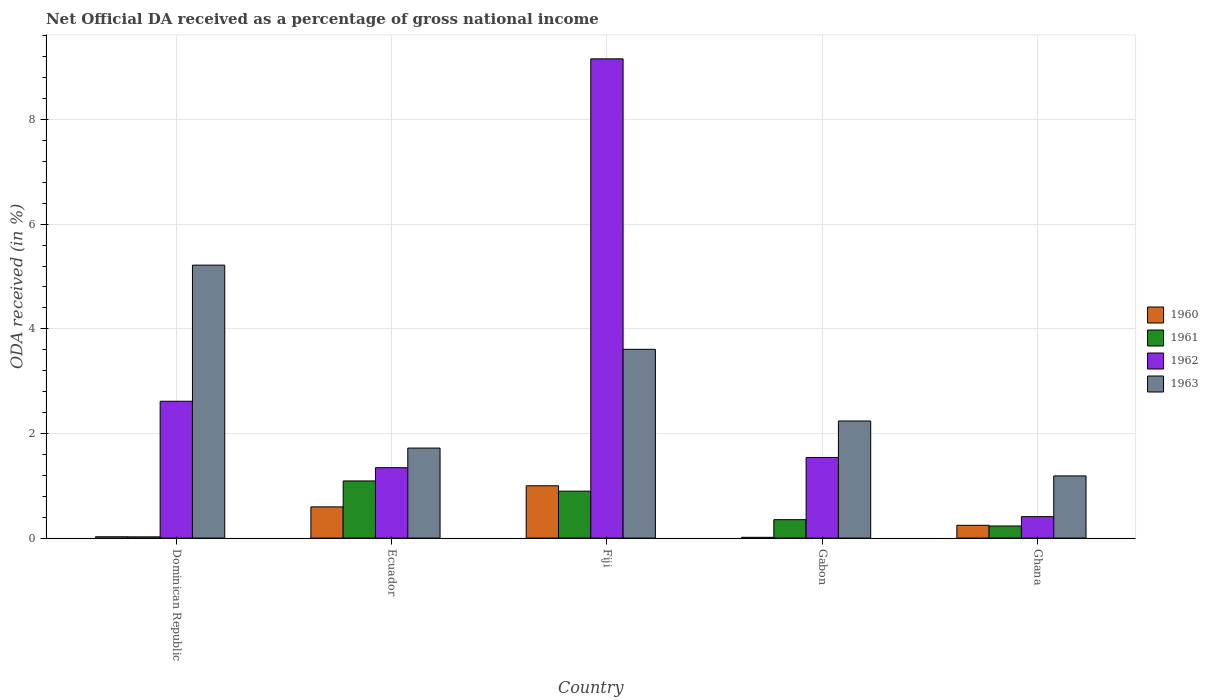How many bars are there on the 1st tick from the left?
Your answer should be very brief. 4. What is the label of the 4th group of bars from the left?
Your answer should be compact. Gabon. In how many cases, is the number of bars for a given country not equal to the number of legend labels?
Offer a terse response. 0. What is the net official DA received in 1963 in Gabon?
Give a very brief answer. 2.24. Across all countries, what is the maximum net official DA received in 1961?
Your response must be concise. 1.09. Across all countries, what is the minimum net official DA received in 1960?
Ensure brevity in your answer.  0.01. In which country was the net official DA received in 1962 maximum?
Make the answer very short. Fiji. In which country was the net official DA received in 1960 minimum?
Keep it short and to the point. Gabon. What is the total net official DA received in 1960 in the graph?
Provide a succinct answer. 1.88. What is the difference between the net official DA received in 1961 in Gabon and that in Ghana?
Provide a succinct answer. 0.12. What is the difference between the net official DA received in 1962 in Fiji and the net official DA received in 1963 in Gabon?
Offer a terse response. 6.92. What is the average net official DA received in 1960 per country?
Provide a short and direct response. 0.38. What is the difference between the net official DA received of/in 1962 and net official DA received of/in 1963 in Ghana?
Keep it short and to the point. -0.78. In how many countries, is the net official DA received in 1961 greater than 3.6 %?
Ensure brevity in your answer.  0. What is the ratio of the net official DA received in 1960 in Gabon to that in Ghana?
Give a very brief answer. 0.06. What is the difference between the highest and the second highest net official DA received in 1962?
Provide a succinct answer. 6.54. What is the difference between the highest and the lowest net official DA received in 1963?
Keep it short and to the point. 4.03. In how many countries, is the net official DA received in 1960 greater than the average net official DA received in 1960 taken over all countries?
Give a very brief answer. 2. Is the sum of the net official DA received in 1963 in Gabon and Ghana greater than the maximum net official DA received in 1961 across all countries?
Your answer should be very brief. Yes. How many bars are there?
Your response must be concise. 20. What is the difference between two consecutive major ticks on the Y-axis?
Your answer should be compact. 2. Does the graph contain grids?
Ensure brevity in your answer.  Yes. How many legend labels are there?
Keep it short and to the point. 4. What is the title of the graph?
Offer a terse response. Net Official DA received as a percentage of gross national income. Does "2009" appear as one of the legend labels in the graph?
Ensure brevity in your answer.  No. What is the label or title of the X-axis?
Your answer should be compact. Country. What is the label or title of the Y-axis?
Ensure brevity in your answer.  ODA received (in %). What is the ODA received (in %) in 1960 in Dominican Republic?
Your answer should be very brief. 0.03. What is the ODA received (in %) in 1961 in Dominican Republic?
Ensure brevity in your answer.  0.02. What is the ODA received (in %) in 1962 in Dominican Republic?
Make the answer very short. 2.62. What is the ODA received (in %) in 1963 in Dominican Republic?
Make the answer very short. 5.22. What is the ODA received (in %) of 1960 in Ecuador?
Your answer should be very brief. 0.6. What is the ODA received (in %) in 1961 in Ecuador?
Your answer should be very brief. 1.09. What is the ODA received (in %) of 1962 in Ecuador?
Keep it short and to the point. 1.35. What is the ODA received (in %) of 1963 in Ecuador?
Your response must be concise. 1.72. What is the ODA received (in %) of 1960 in Fiji?
Your response must be concise. 1. What is the ODA received (in %) in 1961 in Fiji?
Your response must be concise. 0.9. What is the ODA received (in %) in 1962 in Fiji?
Keep it short and to the point. 9.16. What is the ODA received (in %) in 1963 in Fiji?
Provide a succinct answer. 3.61. What is the ODA received (in %) of 1960 in Gabon?
Your answer should be very brief. 0.01. What is the ODA received (in %) of 1961 in Gabon?
Offer a terse response. 0.35. What is the ODA received (in %) of 1962 in Gabon?
Ensure brevity in your answer.  1.54. What is the ODA received (in %) in 1963 in Gabon?
Offer a terse response. 2.24. What is the ODA received (in %) in 1960 in Ghana?
Provide a succinct answer. 0.24. What is the ODA received (in %) in 1961 in Ghana?
Ensure brevity in your answer.  0.23. What is the ODA received (in %) of 1962 in Ghana?
Provide a succinct answer. 0.41. What is the ODA received (in %) of 1963 in Ghana?
Make the answer very short. 1.19. Across all countries, what is the maximum ODA received (in %) of 1960?
Keep it short and to the point. 1. Across all countries, what is the maximum ODA received (in %) in 1961?
Your response must be concise. 1.09. Across all countries, what is the maximum ODA received (in %) in 1962?
Provide a short and direct response. 9.16. Across all countries, what is the maximum ODA received (in %) of 1963?
Your response must be concise. 5.22. Across all countries, what is the minimum ODA received (in %) in 1960?
Provide a succinct answer. 0.01. Across all countries, what is the minimum ODA received (in %) of 1961?
Keep it short and to the point. 0.02. Across all countries, what is the minimum ODA received (in %) of 1962?
Provide a short and direct response. 0.41. Across all countries, what is the minimum ODA received (in %) of 1963?
Ensure brevity in your answer.  1.19. What is the total ODA received (in %) in 1960 in the graph?
Make the answer very short. 1.88. What is the total ODA received (in %) in 1961 in the graph?
Make the answer very short. 2.6. What is the total ODA received (in %) of 1962 in the graph?
Make the answer very short. 15.07. What is the total ODA received (in %) in 1963 in the graph?
Your answer should be very brief. 13.97. What is the difference between the ODA received (in %) of 1960 in Dominican Republic and that in Ecuador?
Provide a short and direct response. -0.57. What is the difference between the ODA received (in %) in 1961 in Dominican Republic and that in Ecuador?
Your answer should be very brief. -1.07. What is the difference between the ODA received (in %) of 1962 in Dominican Republic and that in Ecuador?
Provide a succinct answer. 1.27. What is the difference between the ODA received (in %) of 1963 in Dominican Republic and that in Ecuador?
Provide a short and direct response. 3.5. What is the difference between the ODA received (in %) in 1960 in Dominican Republic and that in Fiji?
Make the answer very short. -0.97. What is the difference between the ODA received (in %) in 1961 in Dominican Republic and that in Fiji?
Ensure brevity in your answer.  -0.87. What is the difference between the ODA received (in %) in 1962 in Dominican Republic and that in Fiji?
Offer a terse response. -6.54. What is the difference between the ODA received (in %) in 1963 in Dominican Republic and that in Fiji?
Your answer should be very brief. 1.61. What is the difference between the ODA received (in %) in 1960 in Dominican Republic and that in Gabon?
Provide a succinct answer. 0.01. What is the difference between the ODA received (in %) in 1961 in Dominican Republic and that in Gabon?
Your response must be concise. -0.33. What is the difference between the ODA received (in %) of 1962 in Dominican Republic and that in Gabon?
Your response must be concise. 1.07. What is the difference between the ODA received (in %) in 1963 in Dominican Republic and that in Gabon?
Provide a succinct answer. 2.98. What is the difference between the ODA received (in %) in 1960 in Dominican Republic and that in Ghana?
Offer a terse response. -0.22. What is the difference between the ODA received (in %) in 1961 in Dominican Republic and that in Ghana?
Offer a terse response. -0.21. What is the difference between the ODA received (in %) of 1962 in Dominican Republic and that in Ghana?
Keep it short and to the point. 2.21. What is the difference between the ODA received (in %) of 1963 in Dominican Republic and that in Ghana?
Make the answer very short. 4.03. What is the difference between the ODA received (in %) in 1960 in Ecuador and that in Fiji?
Give a very brief answer. -0.4. What is the difference between the ODA received (in %) of 1961 in Ecuador and that in Fiji?
Give a very brief answer. 0.2. What is the difference between the ODA received (in %) in 1962 in Ecuador and that in Fiji?
Keep it short and to the point. -7.81. What is the difference between the ODA received (in %) of 1963 in Ecuador and that in Fiji?
Provide a succinct answer. -1.89. What is the difference between the ODA received (in %) in 1960 in Ecuador and that in Gabon?
Provide a succinct answer. 0.58. What is the difference between the ODA received (in %) of 1961 in Ecuador and that in Gabon?
Provide a short and direct response. 0.74. What is the difference between the ODA received (in %) of 1962 in Ecuador and that in Gabon?
Offer a very short reply. -0.2. What is the difference between the ODA received (in %) of 1963 in Ecuador and that in Gabon?
Make the answer very short. -0.52. What is the difference between the ODA received (in %) in 1960 in Ecuador and that in Ghana?
Provide a succinct answer. 0.35. What is the difference between the ODA received (in %) of 1961 in Ecuador and that in Ghana?
Make the answer very short. 0.86. What is the difference between the ODA received (in %) in 1962 in Ecuador and that in Ghana?
Offer a very short reply. 0.94. What is the difference between the ODA received (in %) in 1963 in Ecuador and that in Ghana?
Your answer should be compact. 0.53. What is the difference between the ODA received (in %) of 1960 in Fiji and that in Gabon?
Give a very brief answer. 0.98. What is the difference between the ODA received (in %) in 1961 in Fiji and that in Gabon?
Your answer should be very brief. 0.55. What is the difference between the ODA received (in %) in 1962 in Fiji and that in Gabon?
Provide a short and direct response. 7.62. What is the difference between the ODA received (in %) in 1963 in Fiji and that in Gabon?
Your answer should be very brief. 1.37. What is the difference between the ODA received (in %) of 1960 in Fiji and that in Ghana?
Offer a terse response. 0.76. What is the difference between the ODA received (in %) of 1961 in Fiji and that in Ghana?
Ensure brevity in your answer.  0.67. What is the difference between the ODA received (in %) of 1962 in Fiji and that in Ghana?
Provide a succinct answer. 8.75. What is the difference between the ODA received (in %) of 1963 in Fiji and that in Ghana?
Ensure brevity in your answer.  2.42. What is the difference between the ODA received (in %) in 1960 in Gabon and that in Ghana?
Your response must be concise. -0.23. What is the difference between the ODA received (in %) of 1961 in Gabon and that in Ghana?
Ensure brevity in your answer.  0.12. What is the difference between the ODA received (in %) of 1962 in Gabon and that in Ghana?
Your answer should be very brief. 1.13. What is the difference between the ODA received (in %) in 1963 in Gabon and that in Ghana?
Offer a very short reply. 1.05. What is the difference between the ODA received (in %) in 1960 in Dominican Republic and the ODA received (in %) in 1961 in Ecuador?
Make the answer very short. -1.07. What is the difference between the ODA received (in %) of 1960 in Dominican Republic and the ODA received (in %) of 1962 in Ecuador?
Make the answer very short. -1.32. What is the difference between the ODA received (in %) in 1960 in Dominican Republic and the ODA received (in %) in 1963 in Ecuador?
Ensure brevity in your answer.  -1.69. What is the difference between the ODA received (in %) of 1961 in Dominican Republic and the ODA received (in %) of 1962 in Ecuador?
Your response must be concise. -1.32. What is the difference between the ODA received (in %) of 1961 in Dominican Republic and the ODA received (in %) of 1963 in Ecuador?
Your answer should be very brief. -1.7. What is the difference between the ODA received (in %) in 1962 in Dominican Republic and the ODA received (in %) in 1963 in Ecuador?
Ensure brevity in your answer.  0.9. What is the difference between the ODA received (in %) of 1960 in Dominican Republic and the ODA received (in %) of 1961 in Fiji?
Make the answer very short. -0.87. What is the difference between the ODA received (in %) of 1960 in Dominican Republic and the ODA received (in %) of 1962 in Fiji?
Offer a terse response. -9.13. What is the difference between the ODA received (in %) in 1960 in Dominican Republic and the ODA received (in %) in 1963 in Fiji?
Offer a very short reply. -3.58. What is the difference between the ODA received (in %) in 1961 in Dominican Republic and the ODA received (in %) in 1962 in Fiji?
Offer a terse response. -9.14. What is the difference between the ODA received (in %) in 1961 in Dominican Republic and the ODA received (in %) in 1963 in Fiji?
Give a very brief answer. -3.58. What is the difference between the ODA received (in %) in 1962 in Dominican Republic and the ODA received (in %) in 1963 in Fiji?
Give a very brief answer. -0.99. What is the difference between the ODA received (in %) in 1960 in Dominican Republic and the ODA received (in %) in 1961 in Gabon?
Offer a very short reply. -0.33. What is the difference between the ODA received (in %) in 1960 in Dominican Republic and the ODA received (in %) in 1962 in Gabon?
Your answer should be compact. -1.52. What is the difference between the ODA received (in %) of 1960 in Dominican Republic and the ODA received (in %) of 1963 in Gabon?
Your answer should be very brief. -2.21. What is the difference between the ODA received (in %) in 1961 in Dominican Republic and the ODA received (in %) in 1962 in Gabon?
Make the answer very short. -1.52. What is the difference between the ODA received (in %) of 1961 in Dominican Republic and the ODA received (in %) of 1963 in Gabon?
Your response must be concise. -2.21. What is the difference between the ODA received (in %) in 1962 in Dominican Republic and the ODA received (in %) in 1963 in Gabon?
Your answer should be compact. 0.38. What is the difference between the ODA received (in %) in 1960 in Dominican Republic and the ODA received (in %) in 1961 in Ghana?
Offer a terse response. -0.21. What is the difference between the ODA received (in %) of 1960 in Dominican Republic and the ODA received (in %) of 1962 in Ghana?
Ensure brevity in your answer.  -0.38. What is the difference between the ODA received (in %) in 1960 in Dominican Republic and the ODA received (in %) in 1963 in Ghana?
Keep it short and to the point. -1.16. What is the difference between the ODA received (in %) of 1961 in Dominican Republic and the ODA received (in %) of 1962 in Ghana?
Provide a short and direct response. -0.39. What is the difference between the ODA received (in %) in 1961 in Dominican Republic and the ODA received (in %) in 1963 in Ghana?
Give a very brief answer. -1.16. What is the difference between the ODA received (in %) of 1962 in Dominican Republic and the ODA received (in %) of 1963 in Ghana?
Ensure brevity in your answer.  1.43. What is the difference between the ODA received (in %) in 1960 in Ecuador and the ODA received (in %) in 1961 in Fiji?
Provide a short and direct response. -0.3. What is the difference between the ODA received (in %) of 1960 in Ecuador and the ODA received (in %) of 1962 in Fiji?
Give a very brief answer. -8.56. What is the difference between the ODA received (in %) of 1960 in Ecuador and the ODA received (in %) of 1963 in Fiji?
Your answer should be compact. -3.01. What is the difference between the ODA received (in %) in 1961 in Ecuador and the ODA received (in %) in 1962 in Fiji?
Your answer should be very brief. -8.07. What is the difference between the ODA received (in %) of 1961 in Ecuador and the ODA received (in %) of 1963 in Fiji?
Your response must be concise. -2.52. What is the difference between the ODA received (in %) of 1962 in Ecuador and the ODA received (in %) of 1963 in Fiji?
Your response must be concise. -2.26. What is the difference between the ODA received (in %) in 1960 in Ecuador and the ODA received (in %) in 1961 in Gabon?
Provide a succinct answer. 0.24. What is the difference between the ODA received (in %) of 1960 in Ecuador and the ODA received (in %) of 1962 in Gabon?
Make the answer very short. -0.94. What is the difference between the ODA received (in %) in 1960 in Ecuador and the ODA received (in %) in 1963 in Gabon?
Your response must be concise. -1.64. What is the difference between the ODA received (in %) in 1961 in Ecuador and the ODA received (in %) in 1962 in Gabon?
Provide a succinct answer. -0.45. What is the difference between the ODA received (in %) in 1961 in Ecuador and the ODA received (in %) in 1963 in Gabon?
Provide a succinct answer. -1.15. What is the difference between the ODA received (in %) in 1962 in Ecuador and the ODA received (in %) in 1963 in Gabon?
Keep it short and to the point. -0.89. What is the difference between the ODA received (in %) of 1960 in Ecuador and the ODA received (in %) of 1961 in Ghana?
Your answer should be compact. 0.36. What is the difference between the ODA received (in %) of 1960 in Ecuador and the ODA received (in %) of 1962 in Ghana?
Provide a short and direct response. 0.19. What is the difference between the ODA received (in %) in 1960 in Ecuador and the ODA received (in %) in 1963 in Ghana?
Your answer should be very brief. -0.59. What is the difference between the ODA received (in %) of 1961 in Ecuador and the ODA received (in %) of 1962 in Ghana?
Keep it short and to the point. 0.68. What is the difference between the ODA received (in %) of 1961 in Ecuador and the ODA received (in %) of 1963 in Ghana?
Your answer should be compact. -0.1. What is the difference between the ODA received (in %) in 1962 in Ecuador and the ODA received (in %) in 1963 in Ghana?
Your answer should be very brief. 0.16. What is the difference between the ODA received (in %) in 1960 in Fiji and the ODA received (in %) in 1961 in Gabon?
Offer a very short reply. 0.65. What is the difference between the ODA received (in %) of 1960 in Fiji and the ODA received (in %) of 1962 in Gabon?
Provide a succinct answer. -0.54. What is the difference between the ODA received (in %) in 1960 in Fiji and the ODA received (in %) in 1963 in Gabon?
Your response must be concise. -1.24. What is the difference between the ODA received (in %) in 1961 in Fiji and the ODA received (in %) in 1962 in Gabon?
Provide a succinct answer. -0.64. What is the difference between the ODA received (in %) of 1961 in Fiji and the ODA received (in %) of 1963 in Gabon?
Offer a terse response. -1.34. What is the difference between the ODA received (in %) of 1962 in Fiji and the ODA received (in %) of 1963 in Gabon?
Your answer should be compact. 6.92. What is the difference between the ODA received (in %) in 1960 in Fiji and the ODA received (in %) in 1961 in Ghana?
Ensure brevity in your answer.  0.77. What is the difference between the ODA received (in %) of 1960 in Fiji and the ODA received (in %) of 1962 in Ghana?
Your answer should be compact. 0.59. What is the difference between the ODA received (in %) in 1960 in Fiji and the ODA received (in %) in 1963 in Ghana?
Your answer should be compact. -0.19. What is the difference between the ODA received (in %) of 1961 in Fiji and the ODA received (in %) of 1962 in Ghana?
Your response must be concise. 0.49. What is the difference between the ODA received (in %) in 1961 in Fiji and the ODA received (in %) in 1963 in Ghana?
Keep it short and to the point. -0.29. What is the difference between the ODA received (in %) of 1962 in Fiji and the ODA received (in %) of 1963 in Ghana?
Provide a short and direct response. 7.97. What is the difference between the ODA received (in %) of 1960 in Gabon and the ODA received (in %) of 1961 in Ghana?
Your answer should be compact. -0.22. What is the difference between the ODA received (in %) in 1960 in Gabon and the ODA received (in %) in 1962 in Ghana?
Your answer should be compact. -0.4. What is the difference between the ODA received (in %) in 1960 in Gabon and the ODA received (in %) in 1963 in Ghana?
Provide a succinct answer. -1.17. What is the difference between the ODA received (in %) of 1961 in Gabon and the ODA received (in %) of 1962 in Ghana?
Your response must be concise. -0.06. What is the difference between the ODA received (in %) in 1961 in Gabon and the ODA received (in %) in 1963 in Ghana?
Make the answer very short. -0.84. What is the difference between the ODA received (in %) in 1962 in Gabon and the ODA received (in %) in 1963 in Ghana?
Provide a short and direct response. 0.35. What is the average ODA received (in %) of 1960 per country?
Offer a very short reply. 0.38. What is the average ODA received (in %) of 1961 per country?
Provide a succinct answer. 0.52. What is the average ODA received (in %) in 1962 per country?
Offer a very short reply. 3.01. What is the average ODA received (in %) of 1963 per country?
Your answer should be very brief. 2.79. What is the difference between the ODA received (in %) of 1960 and ODA received (in %) of 1961 in Dominican Republic?
Make the answer very short. 0. What is the difference between the ODA received (in %) of 1960 and ODA received (in %) of 1962 in Dominican Republic?
Your answer should be very brief. -2.59. What is the difference between the ODA received (in %) in 1960 and ODA received (in %) in 1963 in Dominican Republic?
Offer a terse response. -5.19. What is the difference between the ODA received (in %) of 1961 and ODA received (in %) of 1962 in Dominican Republic?
Your response must be concise. -2.59. What is the difference between the ODA received (in %) in 1961 and ODA received (in %) in 1963 in Dominican Republic?
Offer a very short reply. -5.19. What is the difference between the ODA received (in %) in 1962 and ODA received (in %) in 1963 in Dominican Republic?
Ensure brevity in your answer.  -2.6. What is the difference between the ODA received (in %) of 1960 and ODA received (in %) of 1961 in Ecuador?
Offer a very short reply. -0.5. What is the difference between the ODA received (in %) in 1960 and ODA received (in %) in 1962 in Ecuador?
Your answer should be compact. -0.75. What is the difference between the ODA received (in %) of 1960 and ODA received (in %) of 1963 in Ecuador?
Provide a succinct answer. -1.12. What is the difference between the ODA received (in %) of 1961 and ODA received (in %) of 1962 in Ecuador?
Give a very brief answer. -0.25. What is the difference between the ODA received (in %) in 1961 and ODA received (in %) in 1963 in Ecuador?
Your response must be concise. -0.63. What is the difference between the ODA received (in %) of 1962 and ODA received (in %) of 1963 in Ecuador?
Your answer should be very brief. -0.37. What is the difference between the ODA received (in %) of 1960 and ODA received (in %) of 1961 in Fiji?
Your answer should be very brief. 0.1. What is the difference between the ODA received (in %) of 1960 and ODA received (in %) of 1962 in Fiji?
Keep it short and to the point. -8.16. What is the difference between the ODA received (in %) in 1960 and ODA received (in %) in 1963 in Fiji?
Offer a terse response. -2.61. What is the difference between the ODA received (in %) in 1961 and ODA received (in %) in 1962 in Fiji?
Your answer should be compact. -8.26. What is the difference between the ODA received (in %) of 1961 and ODA received (in %) of 1963 in Fiji?
Make the answer very short. -2.71. What is the difference between the ODA received (in %) in 1962 and ODA received (in %) in 1963 in Fiji?
Offer a very short reply. 5.55. What is the difference between the ODA received (in %) in 1960 and ODA received (in %) in 1961 in Gabon?
Your answer should be compact. -0.34. What is the difference between the ODA received (in %) of 1960 and ODA received (in %) of 1962 in Gabon?
Give a very brief answer. -1.53. What is the difference between the ODA received (in %) of 1960 and ODA received (in %) of 1963 in Gabon?
Keep it short and to the point. -2.22. What is the difference between the ODA received (in %) of 1961 and ODA received (in %) of 1962 in Gabon?
Provide a succinct answer. -1.19. What is the difference between the ODA received (in %) of 1961 and ODA received (in %) of 1963 in Gabon?
Make the answer very short. -1.89. What is the difference between the ODA received (in %) in 1962 and ODA received (in %) in 1963 in Gabon?
Your response must be concise. -0.7. What is the difference between the ODA received (in %) of 1960 and ODA received (in %) of 1961 in Ghana?
Provide a short and direct response. 0.01. What is the difference between the ODA received (in %) of 1960 and ODA received (in %) of 1962 in Ghana?
Your response must be concise. -0.17. What is the difference between the ODA received (in %) in 1960 and ODA received (in %) in 1963 in Ghana?
Keep it short and to the point. -0.94. What is the difference between the ODA received (in %) of 1961 and ODA received (in %) of 1962 in Ghana?
Offer a very short reply. -0.18. What is the difference between the ODA received (in %) in 1961 and ODA received (in %) in 1963 in Ghana?
Offer a very short reply. -0.96. What is the difference between the ODA received (in %) in 1962 and ODA received (in %) in 1963 in Ghana?
Your response must be concise. -0.78. What is the ratio of the ODA received (in %) in 1960 in Dominican Republic to that in Ecuador?
Your answer should be compact. 0.04. What is the ratio of the ODA received (in %) of 1961 in Dominican Republic to that in Ecuador?
Offer a terse response. 0.02. What is the ratio of the ODA received (in %) in 1962 in Dominican Republic to that in Ecuador?
Your answer should be very brief. 1.94. What is the ratio of the ODA received (in %) of 1963 in Dominican Republic to that in Ecuador?
Your answer should be compact. 3.03. What is the ratio of the ODA received (in %) in 1960 in Dominican Republic to that in Fiji?
Offer a very short reply. 0.03. What is the ratio of the ODA received (in %) of 1961 in Dominican Republic to that in Fiji?
Your answer should be very brief. 0.03. What is the ratio of the ODA received (in %) in 1962 in Dominican Republic to that in Fiji?
Your response must be concise. 0.29. What is the ratio of the ODA received (in %) of 1963 in Dominican Republic to that in Fiji?
Give a very brief answer. 1.45. What is the ratio of the ODA received (in %) in 1960 in Dominican Republic to that in Gabon?
Offer a terse response. 1.73. What is the ratio of the ODA received (in %) of 1961 in Dominican Republic to that in Gabon?
Provide a short and direct response. 0.07. What is the ratio of the ODA received (in %) of 1962 in Dominican Republic to that in Gabon?
Make the answer very short. 1.7. What is the ratio of the ODA received (in %) of 1963 in Dominican Republic to that in Gabon?
Your answer should be compact. 2.33. What is the ratio of the ODA received (in %) in 1960 in Dominican Republic to that in Ghana?
Make the answer very short. 0.1. What is the ratio of the ODA received (in %) of 1961 in Dominican Republic to that in Ghana?
Provide a short and direct response. 0.1. What is the ratio of the ODA received (in %) in 1962 in Dominican Republic to that in Ghana?
Ensure brevity in your answer.  6.38. What is the ratio of the ODA received (in %) of 1963 in Dominican Republic to that in Ghana?
Your answer should be very brief. 4.39. What is the ratio of the ODA received (in %) of 1960 in Ecuador to that in Fiji?
Your answer should be compact. 0.6. What is the ratio of the ODA received (in %) in 1961 in Ecuador to that in Fiji?
Make the answer very short. 1.22. What is the ratio of the ODA received (in %) of 1962 in Ecuador to that in Fiji?
Make the answer very short. 0.15. What is the ratio of the ODA received (in %) in 1963 in Ecuador to that in Fiji?
Your response must be concise. 0.48. What is the ratio of the ODA received (in %) of 1960 in Ecuador to that in Gabon?
Your response must be concise. 40.19. What is the ratio of the ODA received (in %) of 1961 in Ecuador to that in Gabon?
Make the answer very short. 3.1. What is the ratio of the ODA received (in %) of 1962 in Ecuador to that in Gabon?
Offer a very short reply. 0.87. What is the ratio of the ODA received (in %) in 1963 in Ecuador to that in Gabon?
Keep it short and to the point. 0.77. What is the ratio of the ODA received (in %) in 1960 in Ecuador to that in Ghana?
Offer a very short reply. 2.44. What is the ratio of the ODA received (in %) of 1961 in Ecuador to that in Ghana?
Your response must be concise. 4.72. What is the ratio of the ODA received (in %) of 1962 in Ecuador to that in Ghana?
Offer a terse response. 3.28. What is the ratio of the ODA received (in %) of 1963 in Ecuador to that in Ghana?
Your answer should be very brief. 1.45. What is the ratio of the ODA received (in %) in 1960 in Fiji to that in Gabon?
Your response must be concise. 67.36. What is the ratio of the ODA received (in %) in 1961 in Fiji to that in Gabon?
Offer a very short reply. 2.55. What is the ratio of the ODA received (in %) in 1962 in Fiji to that in Gabon?
Keep it short and to the point. 5.94. What is the ratio of the ODA received (in %) of 1963 in Fiji to that in Gabon?
Your answer should be very brief. 1.61. What is the ratio of the ODA received (in %) of 1960 in Fiji to that in Ghana?
Give a very brief answer. 4.09. What is the ratio of the ODA received (in %) of 1961 in Fiji to that in Ghana?
Ensure brevity in your answer.  3.88. What is the ratio of the ODA received (in %) of 1962 in Fiji to that in Ghana?
Ensure brevity in your answer.  22.34. What is the ratio of the ODA received (in %) of 1963 in Fiji to that in Ghana?
Offer a very short reply. 3.04. What is the ratio of the ODA received (in %) of 1960 in Gabon to that in Ghana?
Give a very brief answer. 0.06. What is the ratio of the ODA received (in %) in 1961 in Gabon to that in Ghana?
Your answer should be compact. 1.52. What is the ratio of the ODA received (in %) of 1962 in Gabon to that in Ghana?
Give a very brief answer. 3.76. What is the ratio of the ODA received (in %) of 1963 in Gabon to that in Ghana?
Your answer should be very brief. 1.88. What is the difference between the highest and the second highest ODA received (in %) of 1960?
Offer a very short reply. 0.4. What is the difference between the highest and the second highest ODA received (in %) of 1961?
Offer a very short reply. 0.2. What is the difference between the highest and the second highest ODA received (in %) of 1962?
Provide a succinct answer. 6.54. What is the difference between the highest and the second highest ODA received (in %) in 1963?
Your response must be concise. 1.61. What is the difference between the highest and the lowest ODA received (in %) in 1960?
Your response must be concise. 0.98. What is the difference between the highest and the lowest ODA received (in %) in 1961?
Keep it short and to the point. 1.07. What is the difference between the highest and the lowest ODA received (in %) of 1962?
Offer a very short reply. 8.75. What is the difference between the highest and the lowest ODA received (in %) of 1963?
Give a very brief answer. 4.03. 